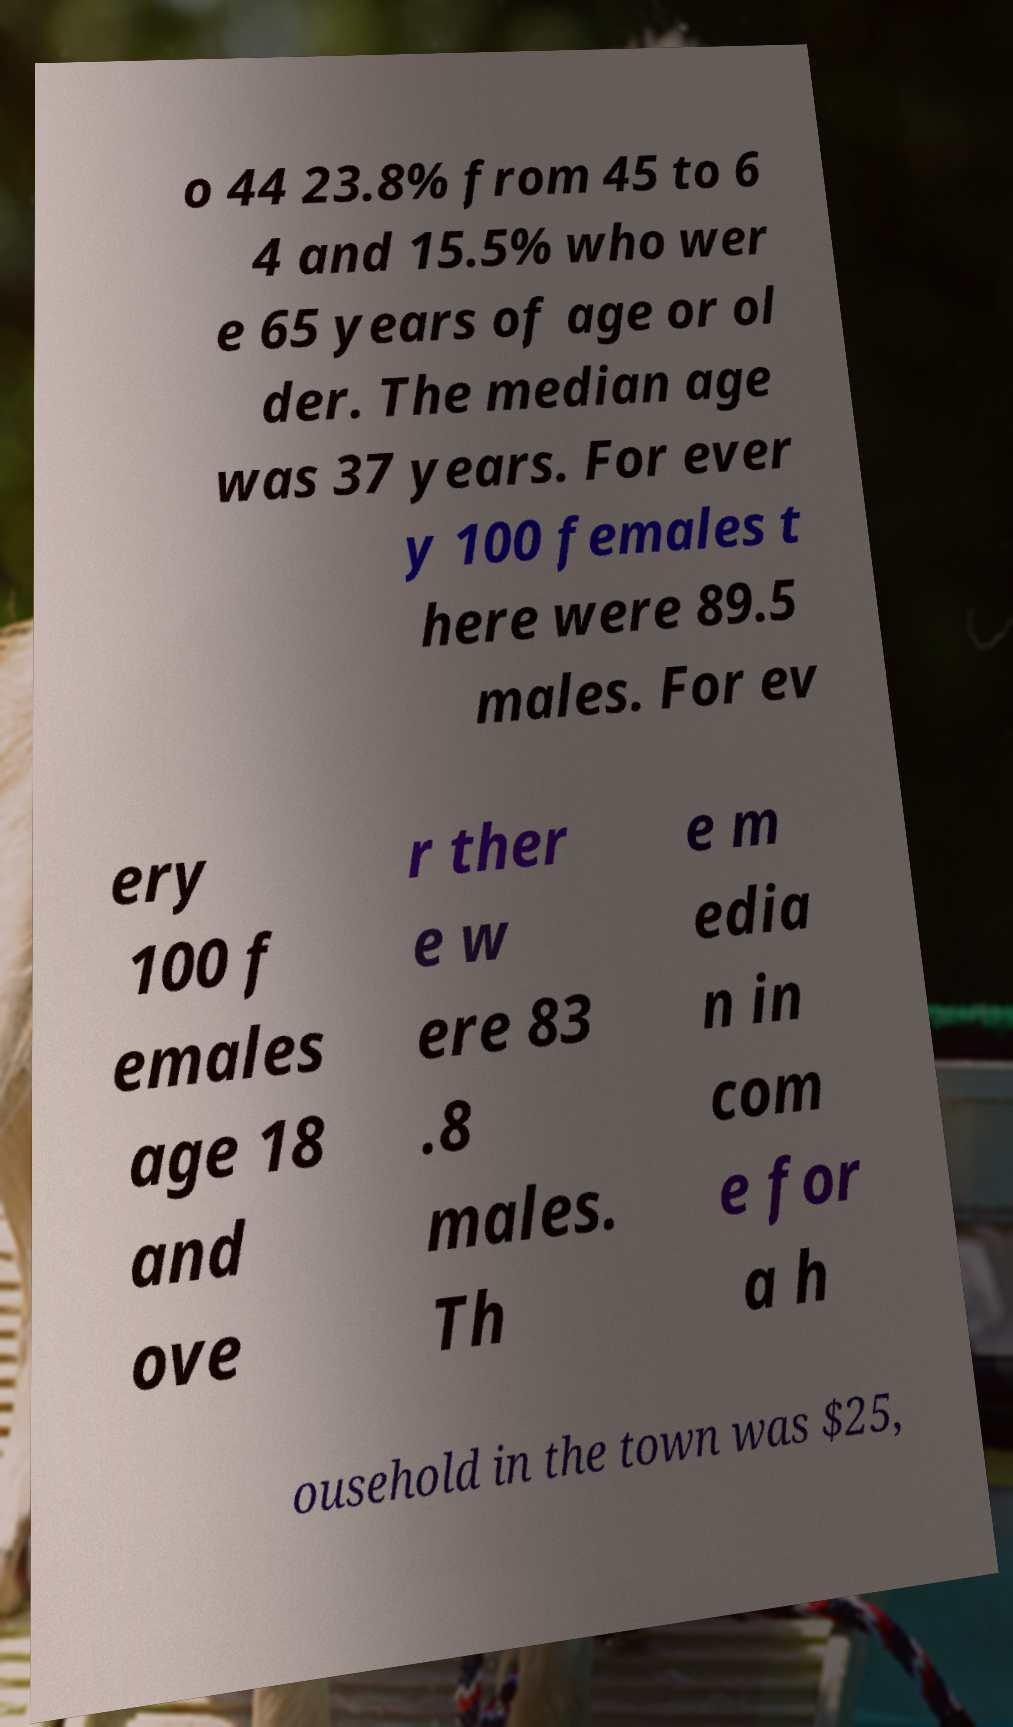Please read and relay the text visible in this image. What does it say? o 44 23.8% from 45 to 6 4 and 15.5% who wer e 65 years of age or ol der. The median age was 37 years. For ever y 100 females t here were 89.5 males. For ev ery 100 f emales age 18 and ove r ther e w ere 83 .8 males. Th e m edia n in com e for a h ousehold in the town was $25, 